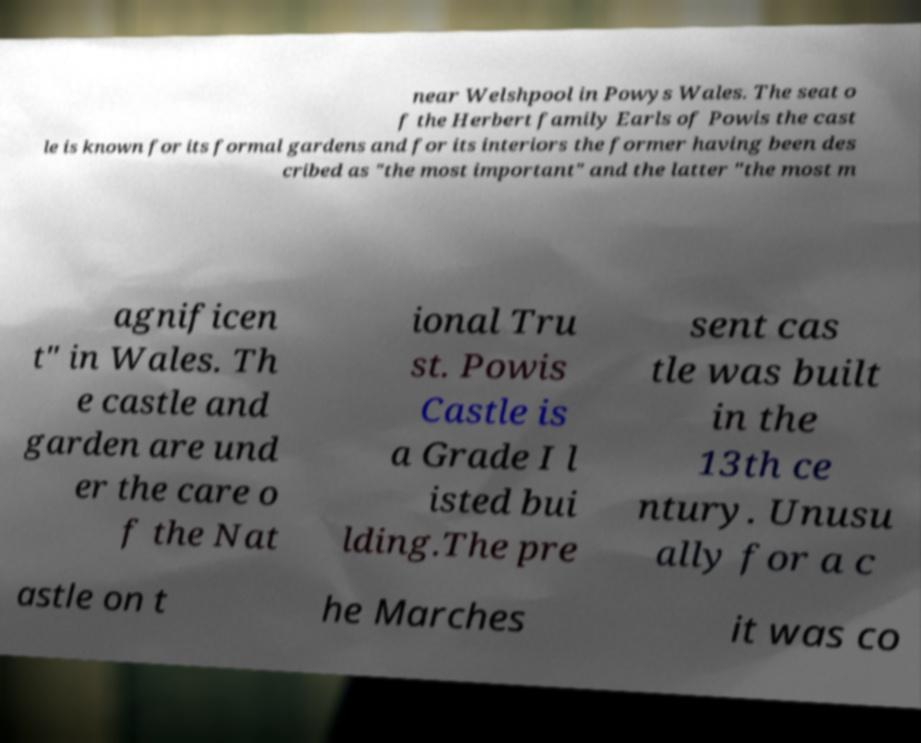Please identify and transcribe the text found in this image. near Welshpool in Powys Wales. The seat o f the Herbert family Earls of Powis the cast le is known for its formal gardens and for its interiors the former having been des cribed as "the most important" and the latter "the most m agnificen t" in Wales. Th e castle and garden are und er the care o f the Nat ional Tru st. Powis Castle is a Grade I l isted bui lding.The pre sent cas tle was built in the 13th ce ntury. Unusu ally for a c astle on t he Marches it was co 